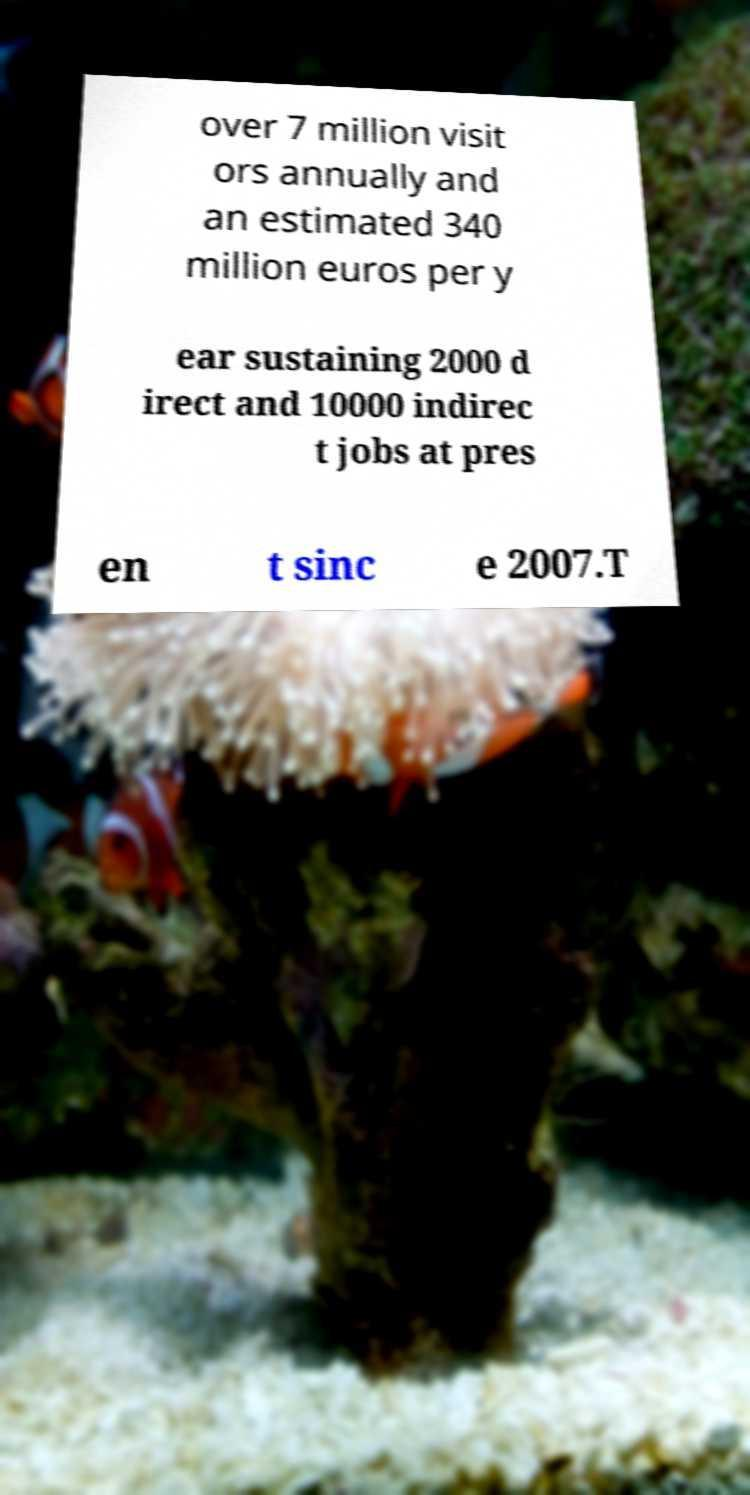Please identify and transcribe the text found in this image. over 7 million visit ors annually and an estimated 340 million euros per y ear sustaining 2000 d irect and 10000 indirec t jobs at pres en t sinc e 2007.T 